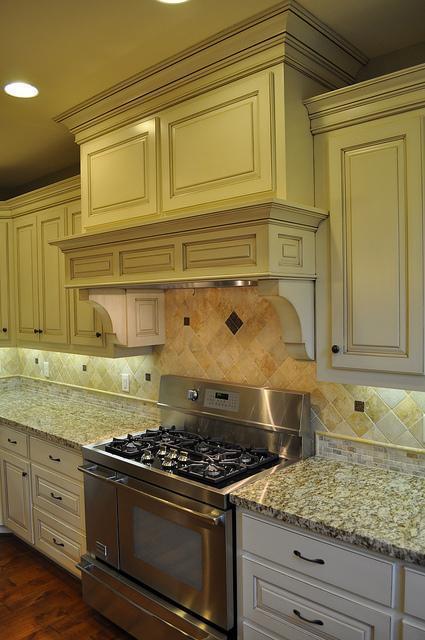How many girls are wearing a green shirt?
Give a very brief answer. 0. 